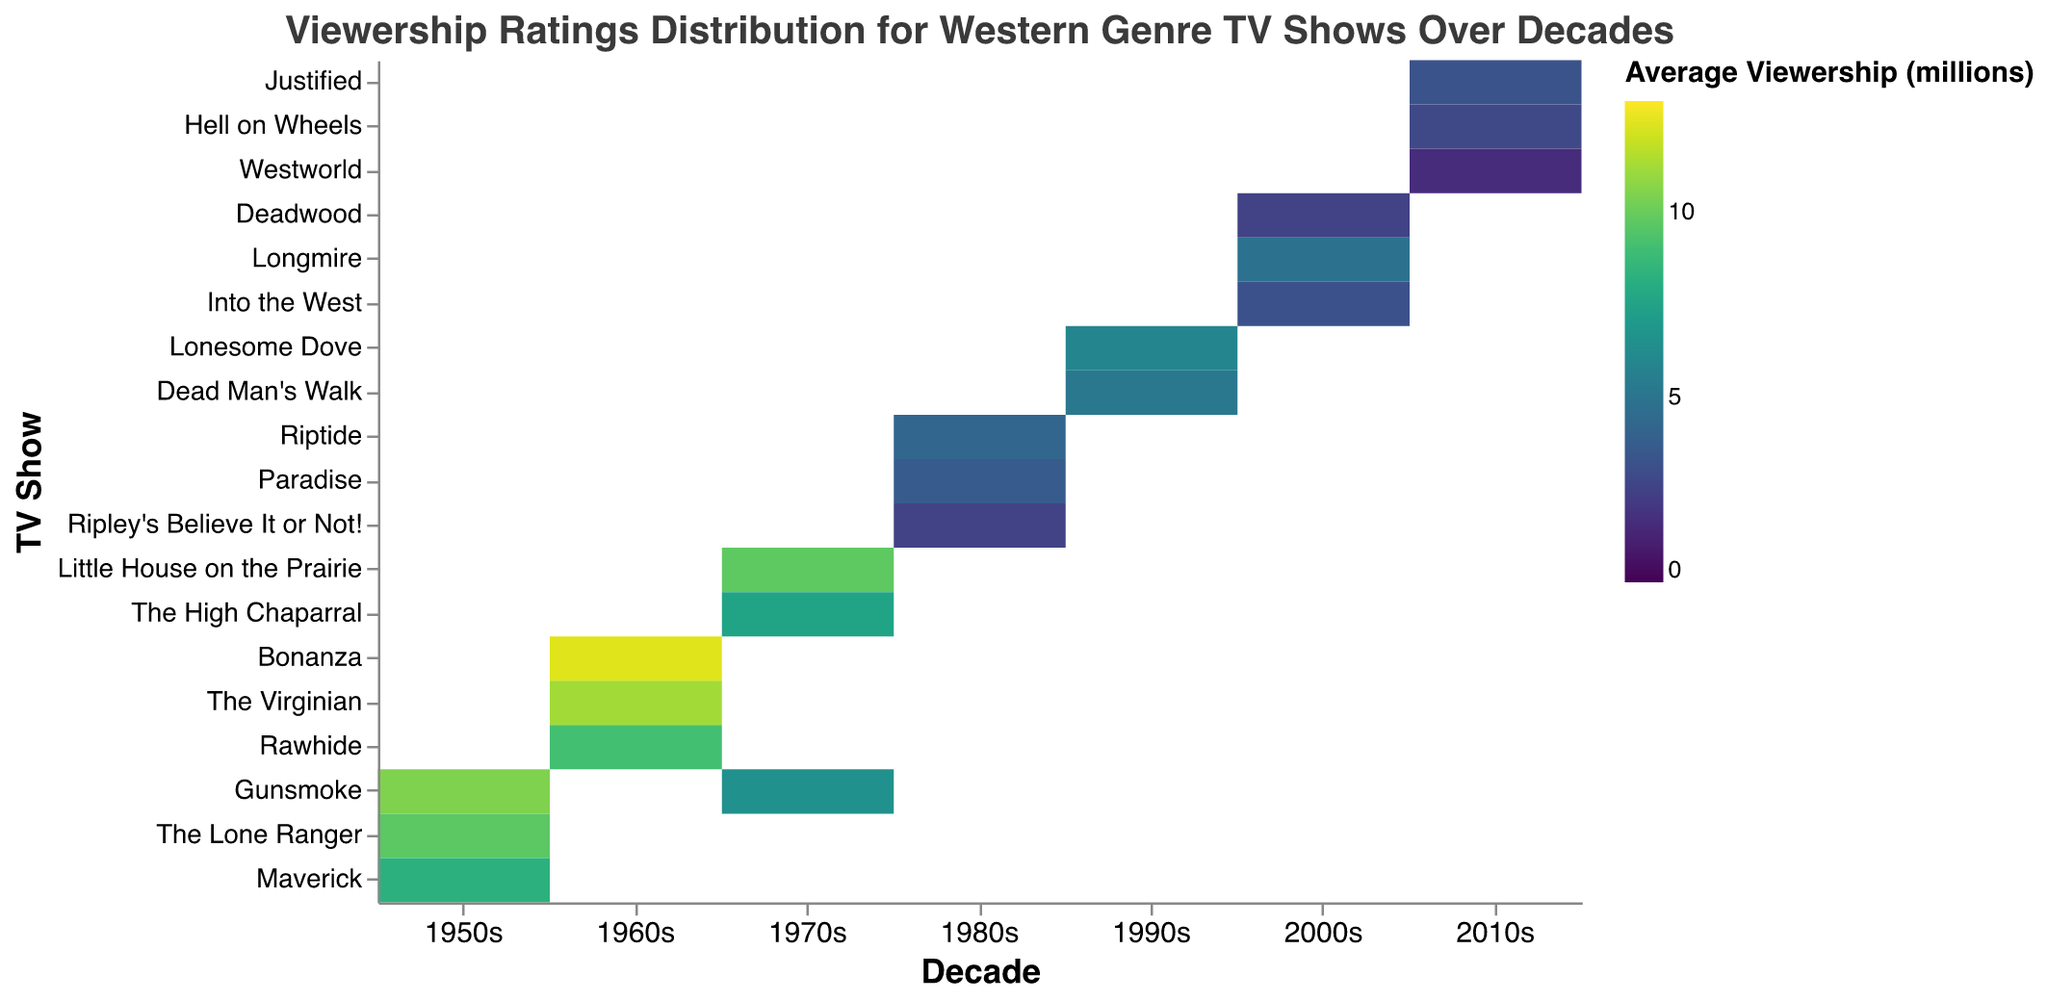What is the title of the heatmap? The title is located at the top of the heatmap. It is the text that gives an overview of the data being presented.
Answer: Viewership Ratings Distribution for Western Genre TV Shows Over Decades Which decade had the highest average viewership rating for Western TV shows? By examining the color intensity on the heatmap, the 1960s have the highest intensity, indicating higher viewership ratings.
Answer: 1960s Among the listed shows, which one has the lowest average viewership rating in the 2010s? On the heatmap, the show with the lightest shade of color in the 2010s column indicates the lowest average viewership rating.
Answer: Westworld How does the average viewership rating for "The Virginian" in the 1960s compare to "Justified" in the 2010s? Find the color intensity for both shows in their respective decades. "The Virginian" has a darker shade indicating a higher rating compared to "Justified" which has a lighter shade.
Answer: The Virginian has a higher rating than Justified What is the range of the average viewership ratings for the shows in the 1980s? Identify the shows listed under the 1980s and note their respective ratings from the color legend. The highest rating is 4.2 for "Riptide" and the lowest is 2.5 for "Ripley's Believe It or Not!"
Answer: 2.5 to 4.2 Which show has the highest viewership rating in the heatmap and what is its rating? The darkest color on the heatmap represents the highest viewership rating. "Bonanza" in the 1960s has this color.
Answer: Bonanza with 12.4 million Compare the average viewership ratings for "Gunsmoke" in the 1950s and 1970s. Which decade had a higher rating? Locate "Gunsmoke" in both the 1950s and 1970s columns. The 1950s has a darker shade indicating a higher rating compared to the 1970s.
Answer: 1950s Which decade shows the most varied viewership ratings for Western TV shows and how can you tell? The decade with the widest range of colors (from light to dark) indicates the most variation. The 1970s show a combination of colors from different intensities.
Answer: 1970s What is the total number of viewership ratings above 5 million in the 1990s? Locate the ratings in the 1990s column and count the entries that have a color intensity indicating ratings above 5 million. "Lonesome Dove" and "Dead Man's Walk" qualify.
Answer: 2 Identify the show with the lowest average viewership rating and state its rating. The show with the lightest color on the heatmap represents the lowest viewership rating. "Westworld" in the 2010s has this lowest color intensity.
Answer: Westworld with 1.6 million 